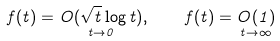<formula> <loc_0><loc_0><loc_500><loc_500>f ( t ) = \underset { t \rightarrow 0 } { O ( \sqrt { t } \log t ) } , \quad f ( t ) = \underset { t \rightarrow \infty } { O ( 1 ) }</formula> 